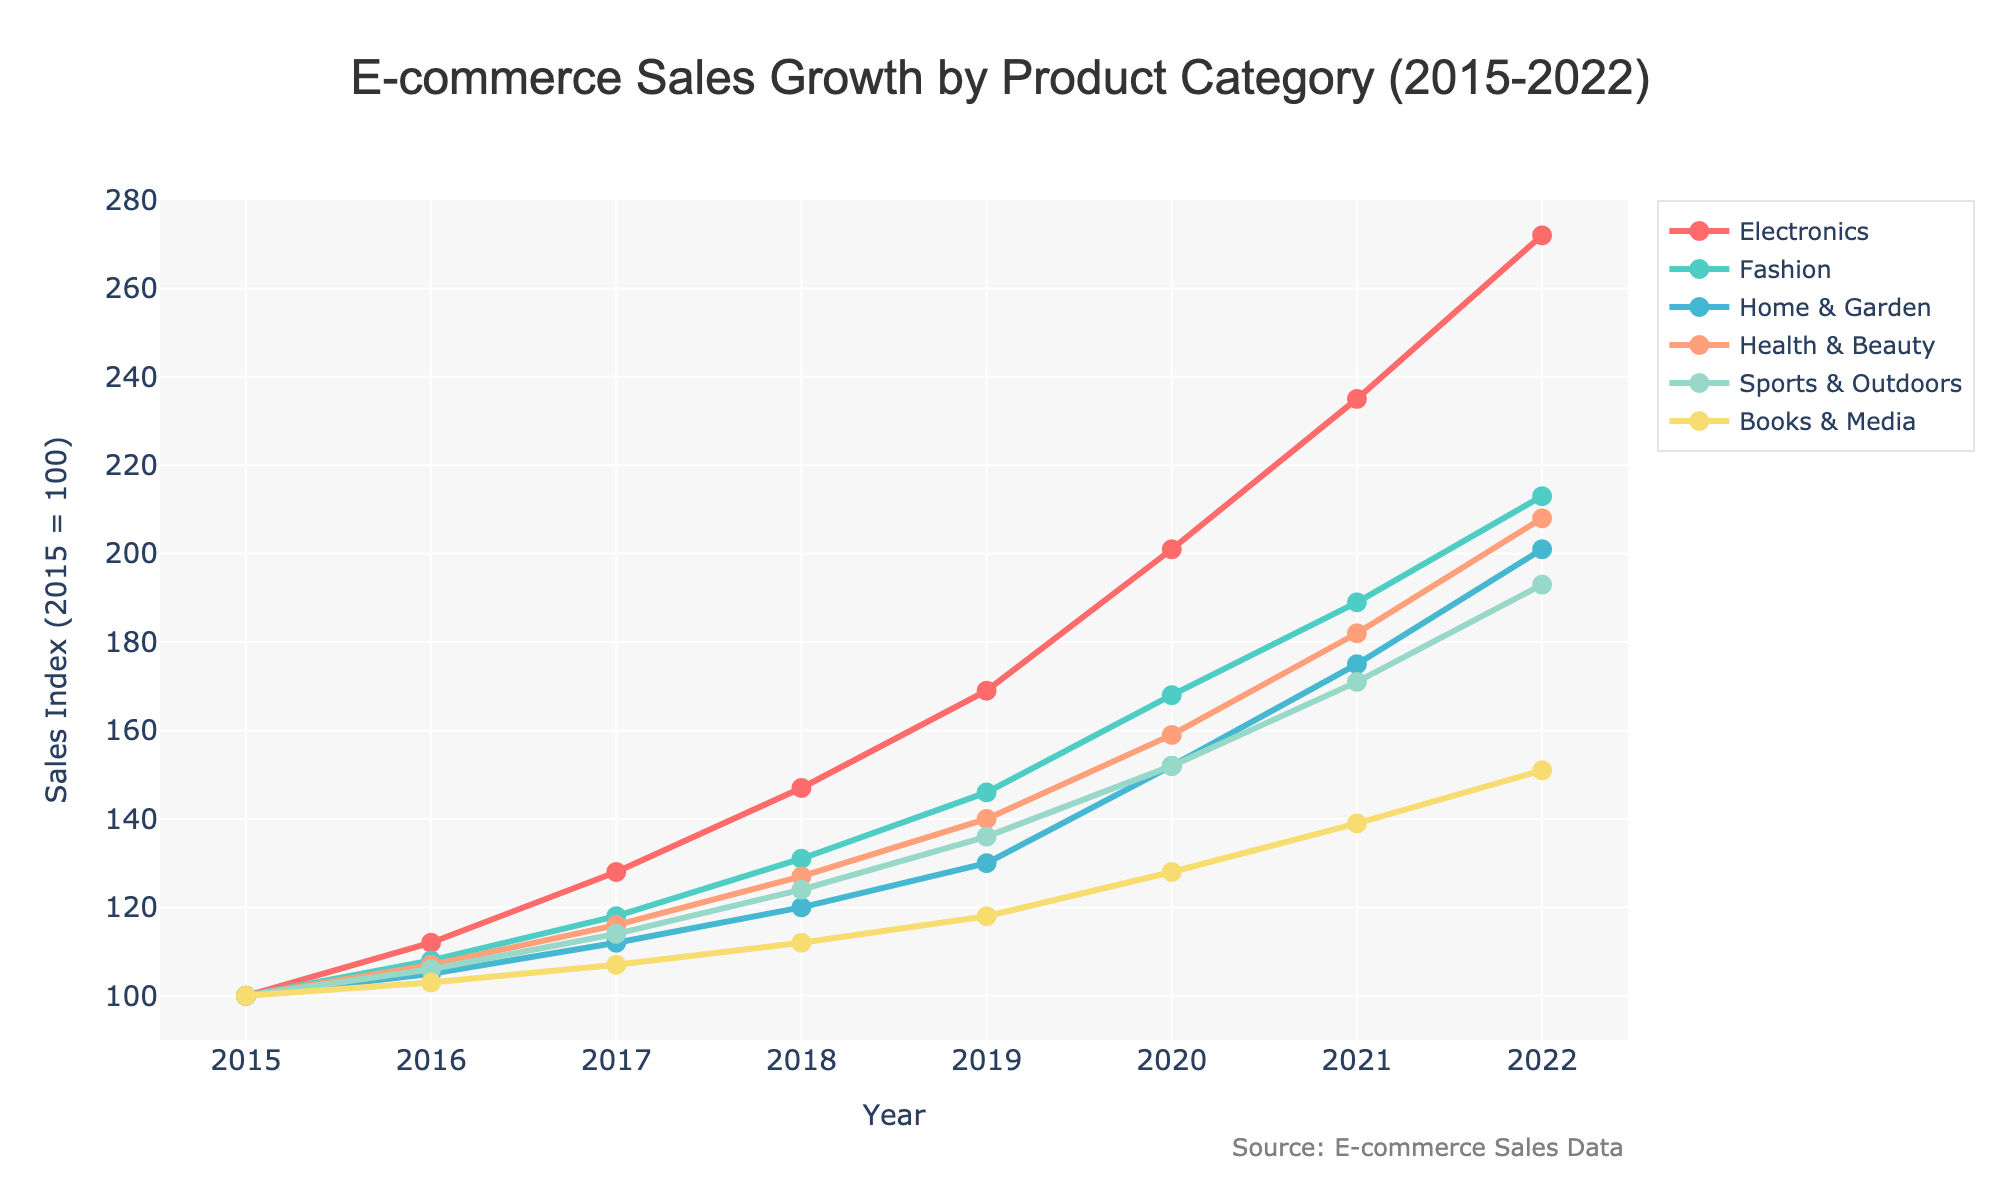What was the sales index for Electronics and Fashion categories in 2022? Check the data points for Electronics and Fashion on the year 2022 in the chart. Electronics is at 272 and Fashion is at 213.
Answer: 272 and 213 Which category had the highest sales index in 2021? Look for the highest point among all categories in the year 2021. Electronics has the highest value at 235.
Answer: Electronics Did Home & Garden or Health & Beauty have a greater increase in sales index from 2017 to 2019? Calculate the difference for Home & Garden (130 - 112 = 18) and for Health & Beauty (140 - 116 = 24) in the given period. Health & Beauty has a greater increase.
Answer: Health & Beauty How did the sales index of Sports & Outdoors change from 2019 to 2022? Note the Sports & Outdoors sales index values in 2019 (136) and 2022 (193). The change is 193 - 136 = 57.
Answer: Increased by 57 Which category showed a consistent annual increase in the sales index every year from 2015 to 2022? Verify for each category whether their sales index showed an increase every year. The Electronics category consistently increased every year.
Answer: Electronics Calculate the average sales index of Books & Media between 2015 and 2022. Sum the sales index values for Books & Media from 2015 to 2022 (100 + 103 + 107 + 112 + 118 + 128 + 139 + 151 = 958) and divide by the number of years (8). The average is 958 / 8 = 119.75.
Answer: 119.75 Compare the growth trends of Electronics and Health & Beauty from 2015 to 2022. Observe the lines representing Electronics and Health & Beauty. Both categories show an increasing trend, but Electronics has a steeper slope, indicating more rapid growth.
Answer: Electronics had more rapid growth What is the difference in the sales index for Fashion between 2018 and 2020? Identify the points for Fashion in 2018 (131) and 2020 (168) and calculate the difference, which is 168 - 131 = 37.
Answer: 37 Which category had the smallest rise in sales index from 2015 to 2022? Check the difference for each category between 2015 and 2022. Books & Media increased from 100 to 151, a rise of 51, which is the smallest among all categories.
Answer: Books & Media 